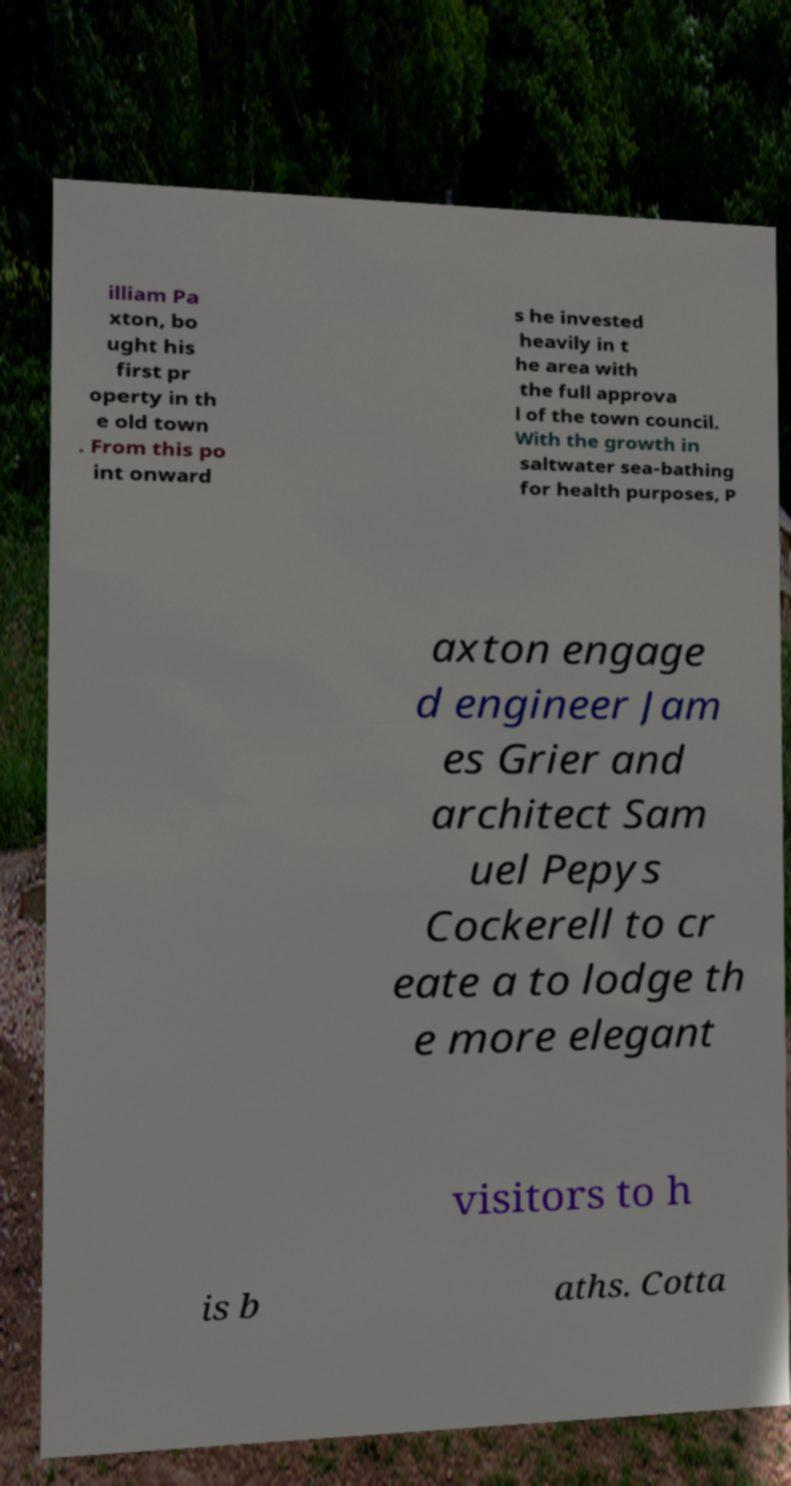I need the written content from this picture converted into text. Can you do that? illiam Pa xton, bo ught his first pr operty in th e old town . From this po int onward s he invested heavily in t he area with the full approva l of the town council. With the growth in saltwater sea-bathing for health purposes, P axton engage d engineer Jam es Grier and architect Sam uel Pepys Cockerell to cr eate a to lodge th e more elegant visitors to h is b aths. Cotta 